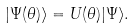Convert formula to latex. <formula><loc_0><loc_0><loc_500><loc_500>| \Psi ( \theta ) \rangle = U ( \theta ) | \Psi \rangle .</formula> 